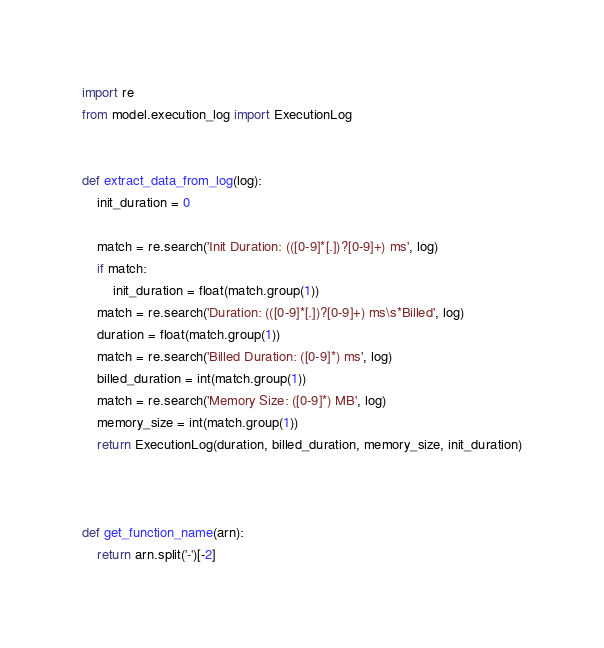Convert code to text. <code><loc_0><loc_0><loc_500><loc_500><_Python_>import re
from model.execution_log import ExecutionLog


def extract_data_from_log(log):
    init_duration = 0

    match = re.search('Init Duration: (([0-9]*[.])?[0-9]+) ms', log)
    if match:
        init_duration = float(match.group(1))
    match = re.search('Duration: (([0-9]*[.])?[0-9]+) ms\s*Billed', log)
    duration = float(match.group(1))
    match = re.search('Billed Duration: ([0-9]*) ms', log)
    billed_duration = int(match.group(1))
    match = re.search('Memory Size: ([0-9]*) MB', log)
    memory_size = int(match.group(1))
    return ExecutionLog(duration, billed_duration, memory_size, init_duration)



def get_function_name(arn):
    return arn.split('-')[-2]
</code> 